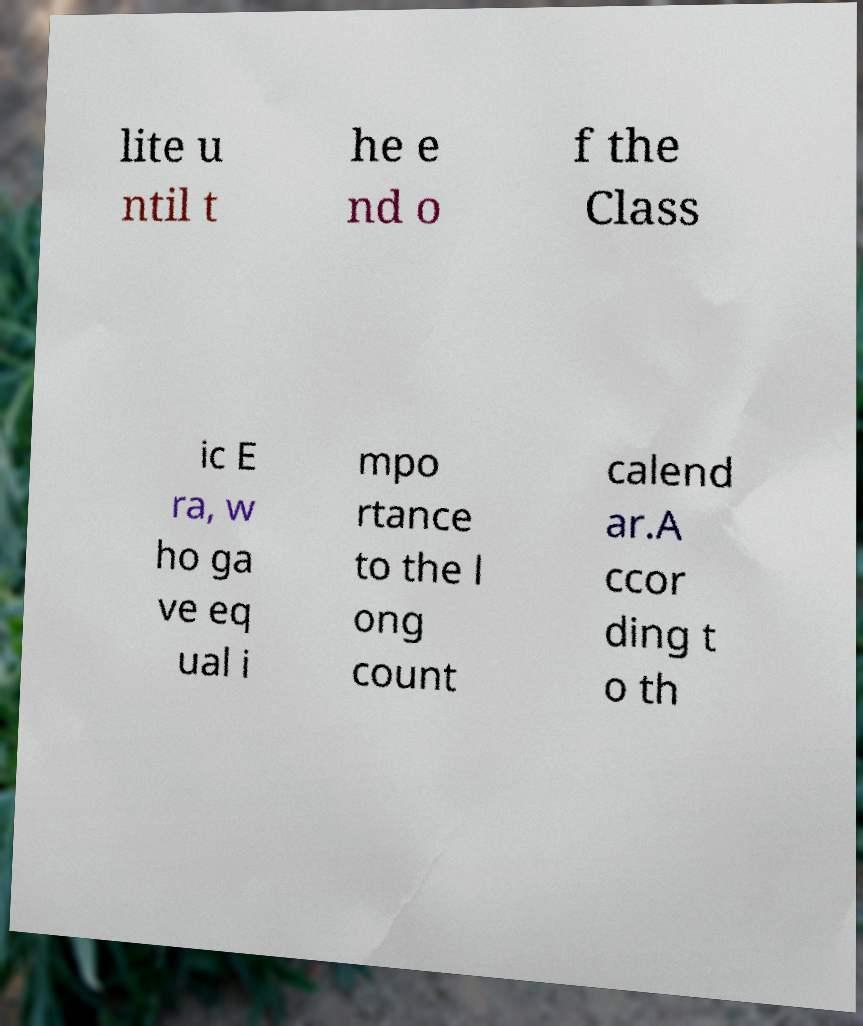What messages or text are displayed in this image? I need them in a readable, typed format. lite u ntil t he e nd o f the Class ic E ra, w ho ga ve eq ual i mpo rtance to the l ong count calend ar.A ccor ding t o th 